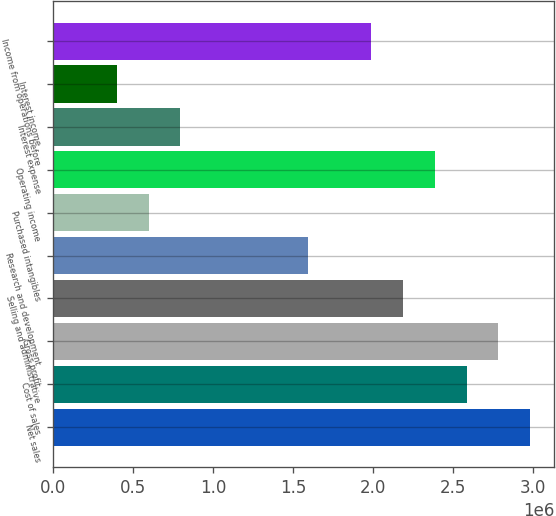Convert chart. <chart><loc_0><loc_0><loc_500><loc_500><bar_chart><fcel>Net sales<fcel>Cost of sales<fcel>Gross profit<fcel>Selling and administrative<fcel>Research and development<fcel>Purchased intangibles<fcel>Operating income<fcel>Interest expense<fcel>Interest income<fcel>Income from operations before<nl><fcel>2.98401e+06<fcel>2.58615e+06<fcel>2.78508e+06<fcel>2.18828e+06<fcel>1.59148e+06<fcel>596807<fcel>2.38721e+06<fcel>795741<fcel>397873<fcel>1.98934e+06<nl></chart> 